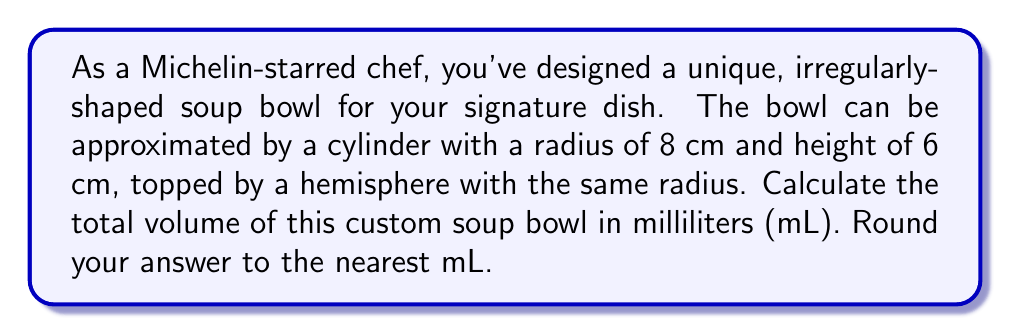Give your solution to this math problem. Let's break this down step-by-step:

1) First, we need to calculate the volume of the cylindrical part:
   $$V_{cylinder} = \pi r^2 h$$
   where $r$ is the radius and $h$ is the height.
   $$V_{cylinder} = \pi (8 \text{ cm})^2 (6 \text{ cm}) = 384\pi \text{ cm}^3$$

2) Next, we calculate the volume of the hemispherical part:
   $$V_{hemisphere} = \frac{2}{3}\pi r^3$$
   $$V_{hemisphere} = \frac{2}{3}\pi (8 \text{ cm})^3 = \frac{1024}{3}\pi \text{ cm}^3$$

3) The total volume is the sum of these two parts:
   $$V_{total} = V_{cylinder} + V_{hemisphere}$$
   $$V_{total} = 384\pi \text{ cm}^3 + \frac{1024}{3}\pi \text{ cm}^3$$
   $$V_{total} = (384 + \frac{1024}{3})\pi \text{ cm}^3$$
   $$V_{total} = \frac{2176}{3}\pi \text{ cm}^3$$

4) Let's calculate this:
   $$V_{total} \approx 2275.66 \text{ cm}^3$$

5) Convert cubic centimeters to milliliters:
   1 cm³ = 1 mL, so the volume in mL is the same number.

6) Rounding to the nearest mL:
   2275.66 mL ≈ 2276 mL
Answer: 2276 mL 